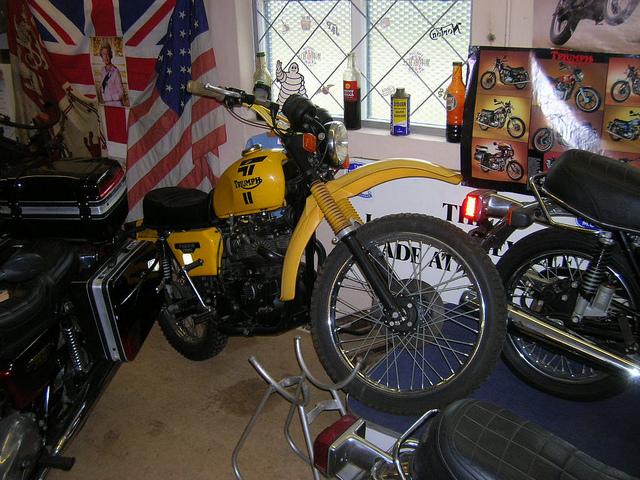How many bikes are in this area?
Keep it brief. 2. Can the bike fit on the trailer?
Give a very brief answer. Yes. How many bikes are in the photo?
Concise answer only. 2. What color is the center bike?
Short answer required. Yellow. Are there mirrors on this vehicle?
Concise answer only. No. 